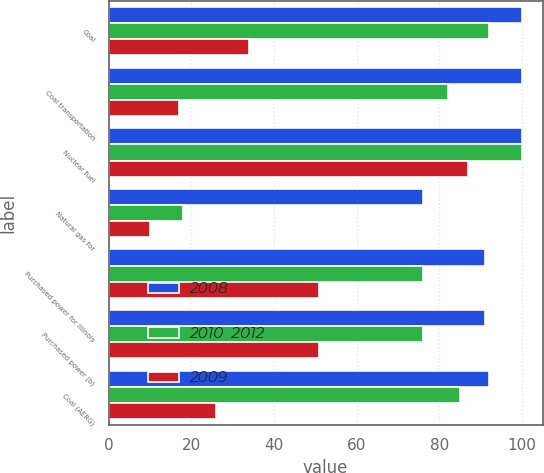Convert chart. <chart><loc_0><loc_0><loc_500><loc_500><stacked_bar_chart><ecel><fcel>Coal<fcel>Coal transportation<fcel>Nuclear fuel<fcel>Natural gas for<fcel>Purchased power for Illinois<fcel>Purchased power (b)<fcel>Coal (AERG)<nl><fcel>2008<fcel>100<fcel>100<fcel>100<fcel>76<fcel>91<fcel>91<fcel>92<nl><fcel>2010  2012<fcel>92<fcel>82<fcel>100<fcel>18<fcel>76<fcel>76<fcel>85<nl><fcel>2009<fcel>34<fcel>17<fcel>87<fcel>10<fcel>51<fcel>51<fcel>26<nl></chart> 